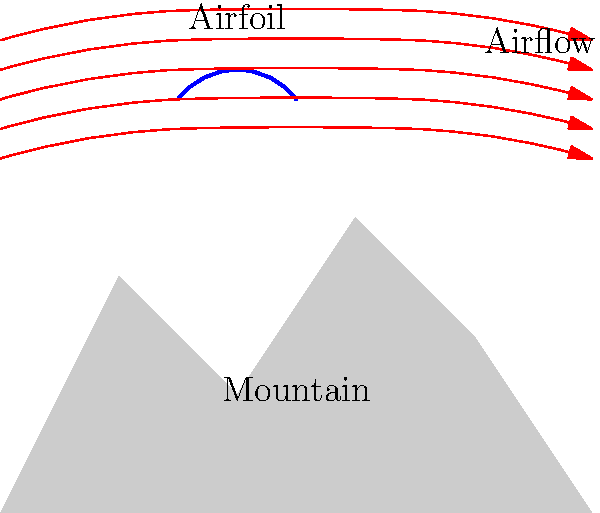In the given graphical representation of airflow patterns around an aircraft wing in mountainous terrain, what phenomenon is likely to occur in the region immediately above the mountain peak, and how might this affect aircraft performance during mountain operations? To answer this question, let's analyze the diagram step-by-step:

1. Mountain shape: The diagram shows a mountain with a peak, creating an obstacle for airflow.

2. Airfoil position: An aircraft wing (airfoil) is positioned above the mountain.

3. Airflow patterns: The red arrows represent the airflow lines around the wing and over the mountain.

4. Airflow compression: As the air approaches the mountain, the streamlines become closer together, indicating compression of the air.

5. Acceleration over the peak: The air accelerates as it moves over the mountain peak, as evidenced by the increased spacing between streamlines just above the peak.

6. Turbulence and vortices: In the region immediately above the mountain peak, the rapid change in airflow direction and speed is likely to create turbulence and possibly mountain wave vortices.

7. Effect on aircraft performance:
   a) Increased lift: The accelerated airflow over the wing can temporarily increase lift.
   b) Unpredictable air currents: Turbulence and vortices can cause sudden changes in lift and drag.
   c) Control difficulties: Rapid changes in airflow can make it challenging to maintain steady flight.
   d) Increased stress on aircraft structure: Turbulence can cause additional stress on the airframe.

8. Implications for mountain operations:
   a) Pilots need to be aware of these phenomena and adjust their flight path accordingly.
   b) Maintenance crews should pay extra attention to structural components that may experience additional stress.
   c) Engineers may need to design specialized systems or procedures to mitigate these effects.

The primary phenomenon occurring above the mountain peak is the formation of turbulence and mountain wave vortices, which can significantly impact aircraft performance and safety during mountain operations.
Answer: Mountain wave turbulence and vortices, affecting lift, control, and structural stress. 